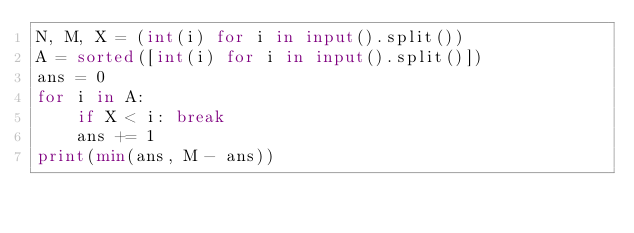Convert code to text. <code><loc_0><loc_0><loc_500><loc_500><_Python_>N, M, X = (int(i) for i in input().split())
A = sorted([int(i) for i in input().split()])
ans = 0
for i in A:
    if X < i: break
    ans += 1
print(min(ans, M - ans))</code> 